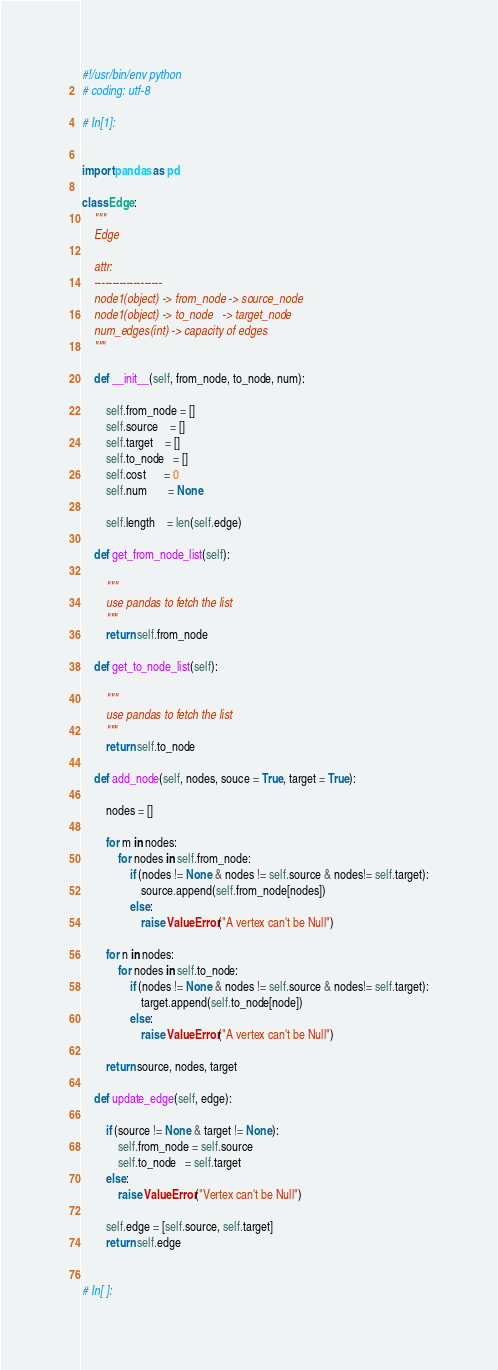<code> <loc_0><loc_0><loc_500><loc_500><_Python_>#!/usr/bin/env python
# coding: utf-8

# In[1]:


import pandas as pd 

class Edge:
    """
    Edge 
    
    attr:
    -------------------
    node1(object) -> from_node -> source_node
    node1(object) -> to_node   -> target_node
    num_edges(int) -> capacity of edges 
    """
    
    def __init__(self, from_node, to_node, num):
        
        self.from_node = []
        self.source    = []
        self.target    = []
        self.to_node   = []
        self.cost      = 0
        self.num       = None

        self.length    = len(self.edge)
        
    def get_from_node_list(self):
        
        """
        use pandas to fetch the list
        """
        return self.from_node
    
    def get_to_node_list(self):
        
        """
        use pandas to fetch the list
        """
        return self.to_node
    
    def add_node(self, nodes, souce = True, target = True):
        
        nodes = []
        
        for m in nodes:
            for nodes in self.from_node:
                if (nodes != None & nodes != self.source & nodes!= self.target):
                    source.append(self.from_node[nodes])
                else:
                    raise ValueError("A vertex can't be Null")
                    
        for n in nodes:
            for nodes in self.to_node:
                if (nodes != None & nodes != self.source & nodes!= self.target):
                    target.append(self.to_node[node])
                else:
                    raise ValueError("A vertex can't be Null")
                    
        return source, nodes, target         
    
    def update_edge(self, edge):
        
        if (source != None & target != None):  
            self.from_node = self.source
            self.to_node   = self.target
        else:
            raise ValueError("Vertex can't be Null")
                             
        self.edge = [self.source, self.target]
        return self.edge 


# In[ ]:




</code> 